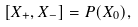<formula> <loc_0><loc_0><loc_500><loc_500>[ X _ { + } , X _ { - } ] = P ( X _ { 0 } ) ,</formula> 